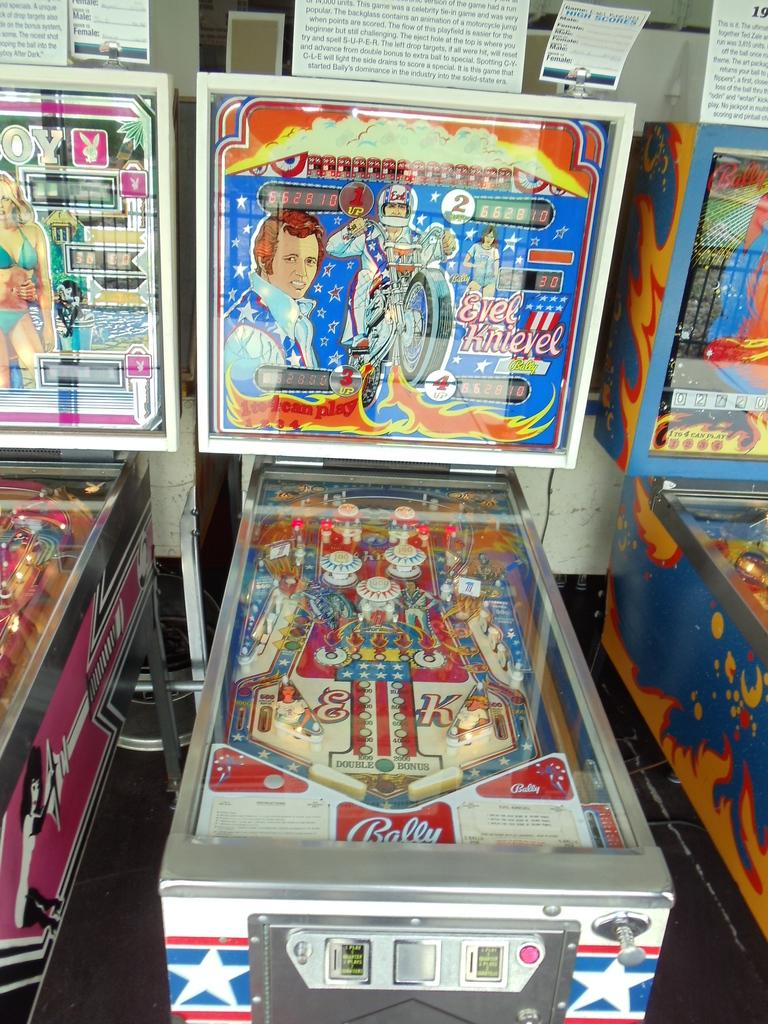<image>
Provide a brief description of the given image. Pinball machine that says Eveel Knievel on it. 